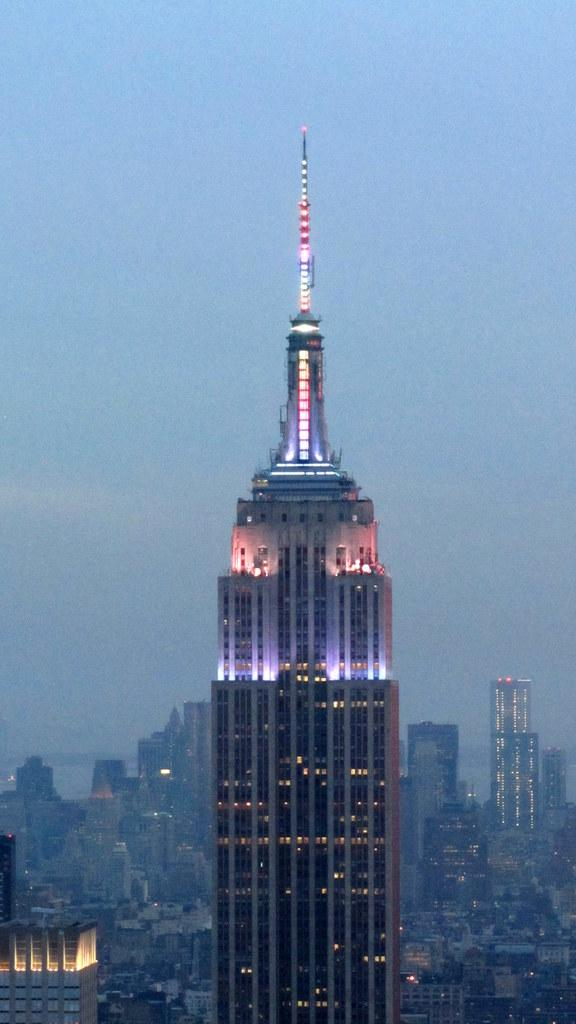What type of structures can be seen in the image? There are buildings, skyscrapers, and a tower in the image. Can you describe the height of any structures in the image? Skyscrapers are present in the image, which are tall buildings. What type of lighting is visible in the image? Electric lights are visible in the image. What can be seen in the background of the image? The sky is visible in the background of the image. How many desks can be seen in the image? There are no desks present in the image. 